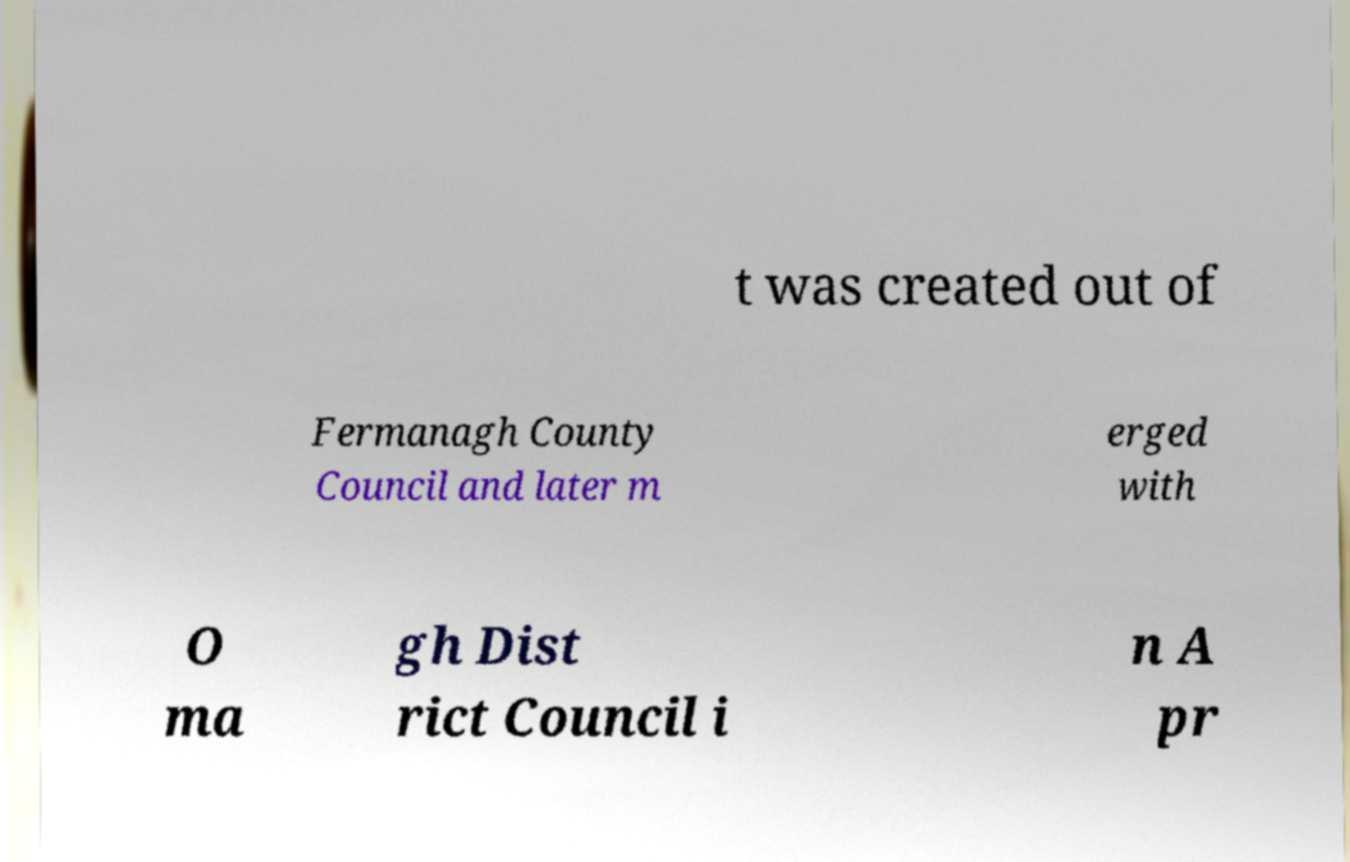Please identify and transcribe the text found in this image. t was created out of Fermanagh County Council and later m erged with O ma gh Dist rict Council i n A pr 